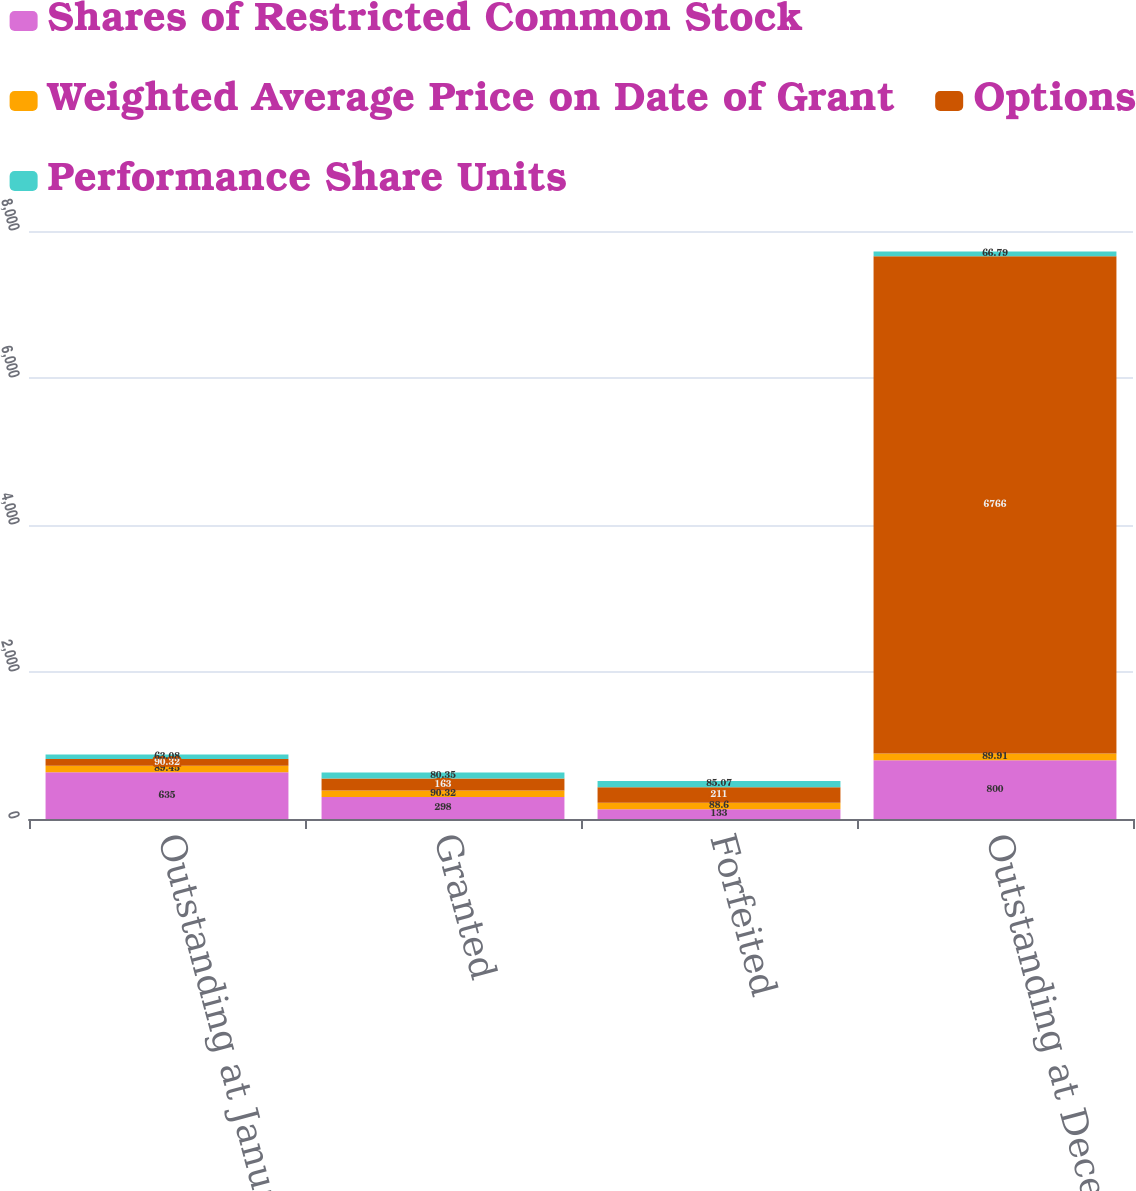Convert chart to OTSL. <chart><loc_0><loc_0><loc_500><loc_500><stacked_bar_chart><ecel><fcel>Outstanding at January 1 2014<fcel>Granted<fcel>Forfeited<fcel>Outstanding at December 31<nl><fcel>Shares of Restricted Common Stock<fcel>635<fcel>298<fcel>133<fcel>800<nl><fcel>Weighted Average Price on Date of Grant<fcel>89.45<fcel>90.32<fcel>88.6<fcel>89.91<nl><fcel>Options<fcel>90.32<fcel>163<fcel>211<fcel>6766<nl><fcel>Performance Share Units<fcel>63.08<fcel>80.35<fcel>85.07<fcel>66.79<nl></chart> 